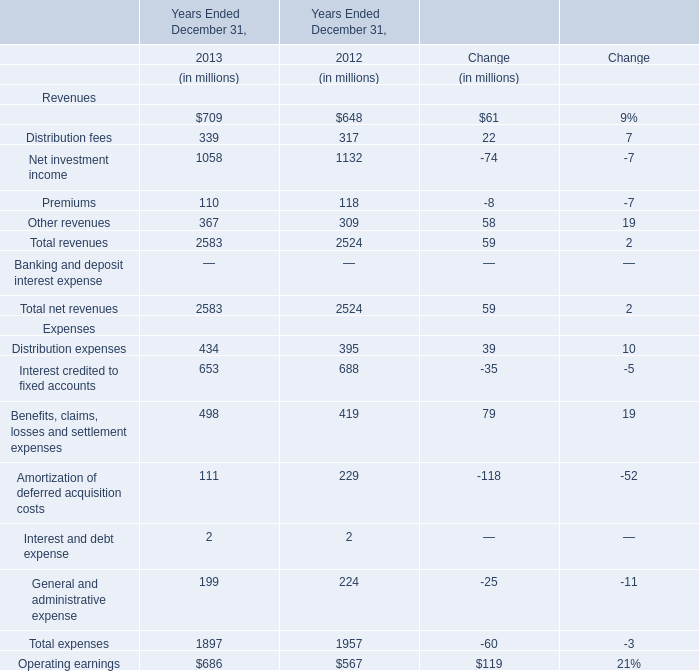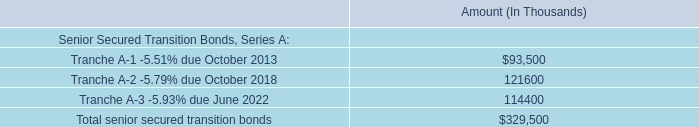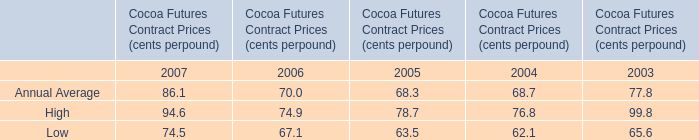what is the principal payment in 2017 as a percentage of the total senior secured transition bonds? 
Computations: ((27.6 * 1000) / 329500)
Answer: 0.08376. 